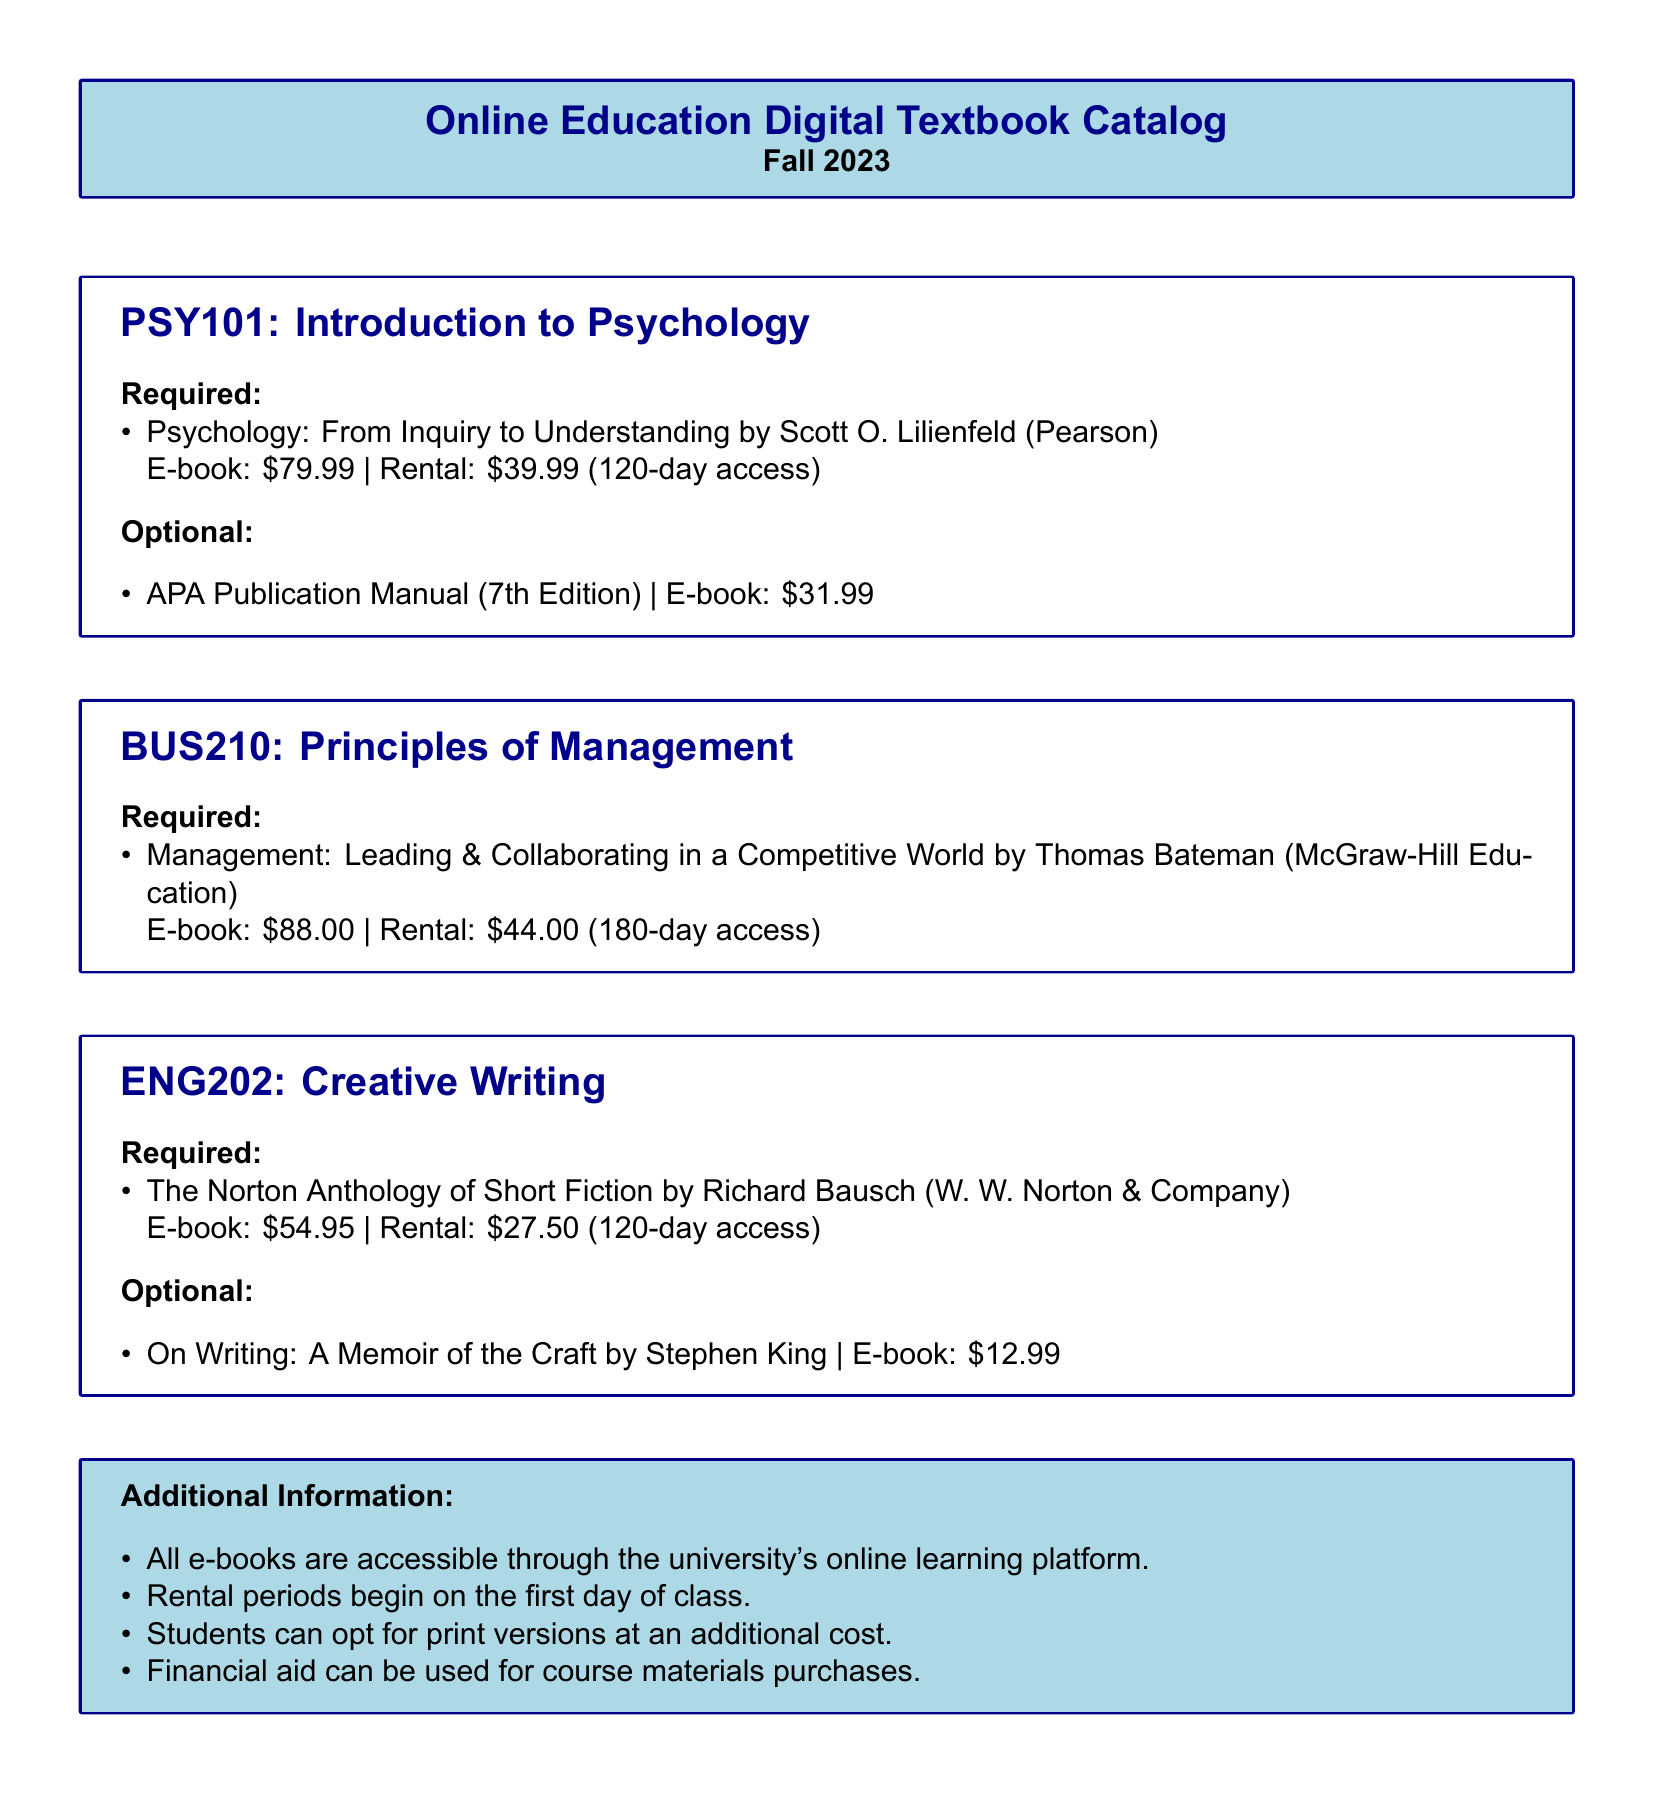What is the price of the e-book for PSY101? The e-book price for PSY101 is specified in the document as $79.99.
Answer: $79.99 What is the rental price for the required book in BUS210? The rental price for the required book in BUS210 is listed as $44.00.
Answer: $44.00 How long is the rental access period for ENG202? The rental access period for the required book in ENG202 is 120 days, as mentioned in the document.
Answer: 120 days What is the optional book for PSY101? The document lists the optional book for PSY101 as the APA Publication Manual (7th Edition).
Answer: APA Publication Manual (7th Edition) Which publisher is associated with the required book for BUS210? The required book for BUS210 is published by McGraw-Hill Education, as stated in the catalog.
Answer: McGraw-Hill Education How much can students spend on e-books through financial aid? The document notes that financial aid can be used for course materials purchases, which includes e-books.
Answer: Not specified What is the title of the required book for ENG202? The title of the required book for ENG202 is The Norton Anthology of Short Fiction.
Answer: The Norton Anthology of Short Fiction What is the total cost of the optional book for ENG202? The cost of the optional book for ENG202 is $12.99.
Answer: $12.99 